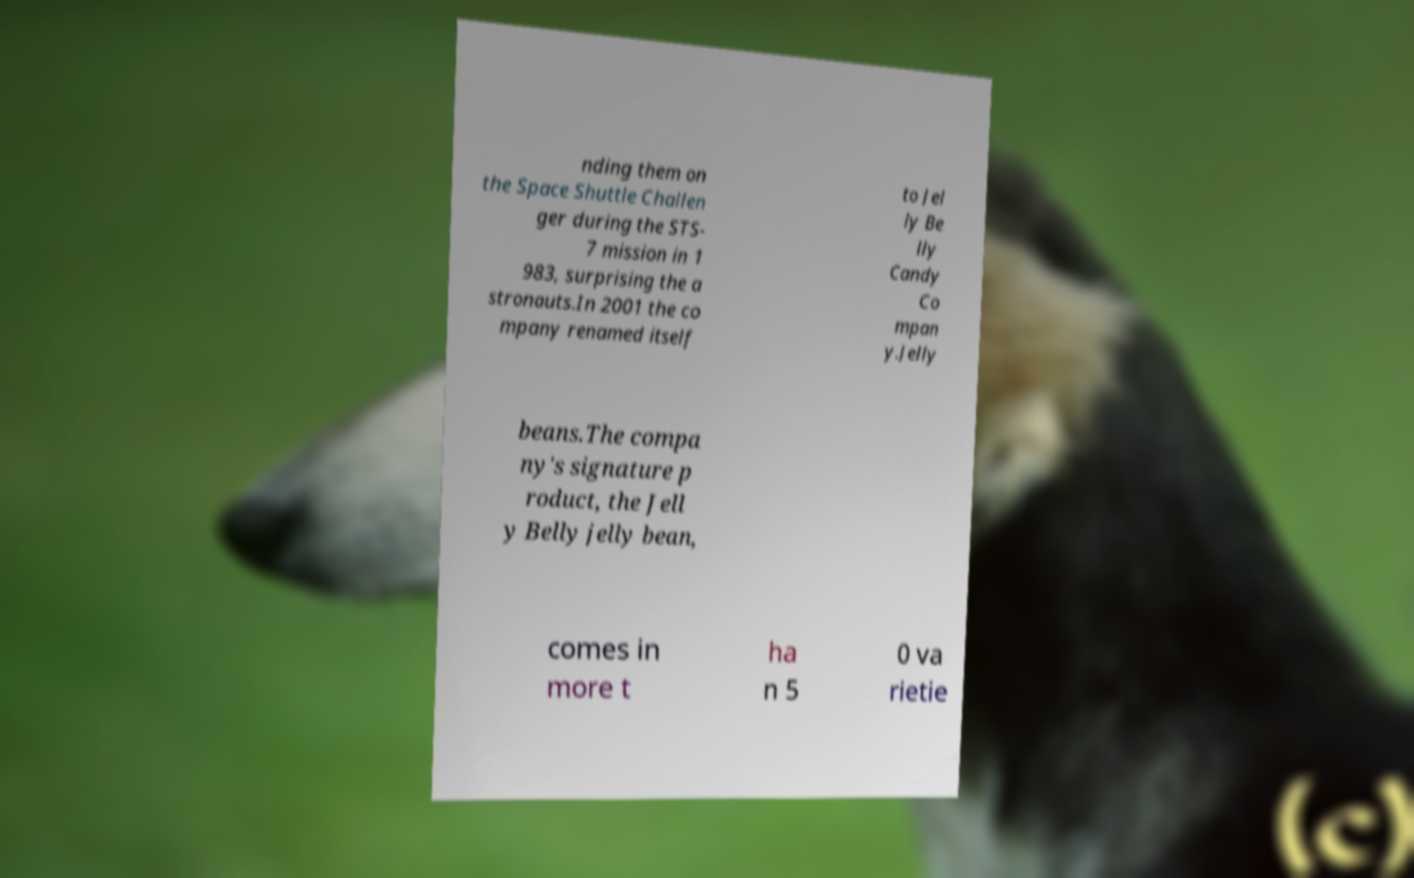I need the written content from this picture converted into text. Can you do that? nding them on the Space Shuttle Challen ger during the STS- 7 mission in 1 983, surprising the a stronauts.In 2001 the co mpany renamed itself to Jel ly Be lly Candy Co mpan y.Jelly beans.The compa ny's signature p roduct, the Jell y Belly jelly bean, comes in more t ha n 5 0 va rietie 